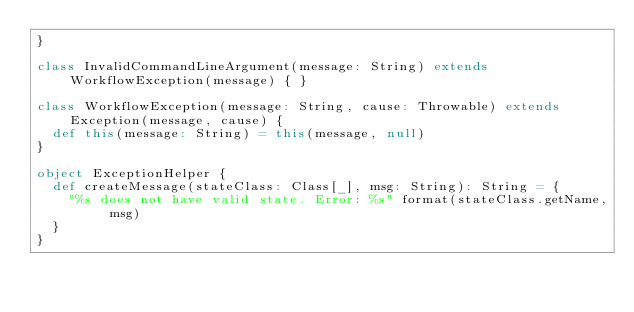<code> <loc_0><loc_0><loc_500><loc_500><_Scala_>}

class InvalidCommandLineArgument(message: String) extends WorkflowException(message) { }

class WorkflowException(message: String, cause: Throwable) extends Exception(message, cause) {
  def this(message: String) = this(message, null)
}

object ExceptionHelper {
  def createMessage(stateClass: Class[_], msg: String): String = {
    "%s does not have valid state. Error: %s" format(stateClass.getName, msg)
  }
}


</code> 